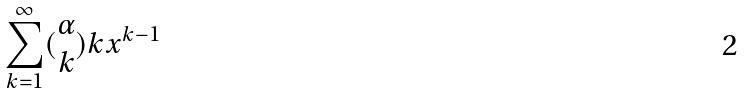Convert formula to latex. <formula><loc_0><loc_0><loc_500><loc_500>\sum _ { k = 1 } ^ { \infty } ( \begin{matrix} \alpha \\ k \end{matrix} ) k x ^ { k - 1 }</formula> 